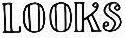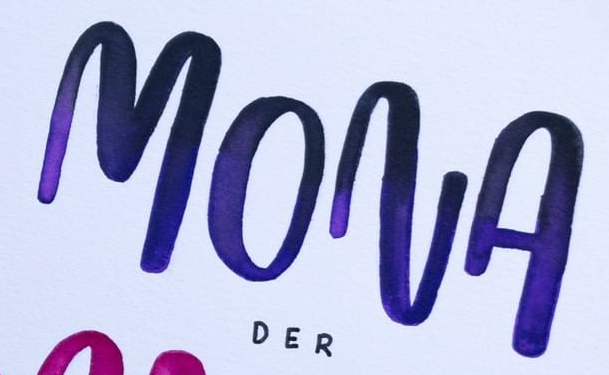What text appears in these images from left to right, separated by a semicolon? LOOKS; MONA 